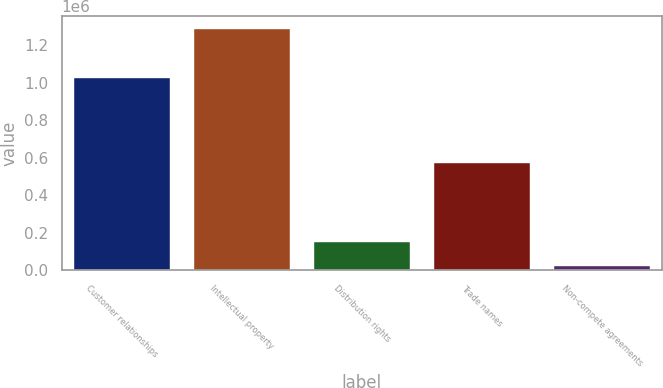<chart> <loc_0><loc_0><loc_500><loc_500><bar_chart><fcel>Customer relationships<fcel>Intellectual property<fcel>Distribution rights<fcel>Trade names<fcel>Non-compete agreements<nl><fcel>1.02384e+06<fcel>1.28749e+06<fcel>149835<fcel>571510<fcel>23429<nl></chart> 